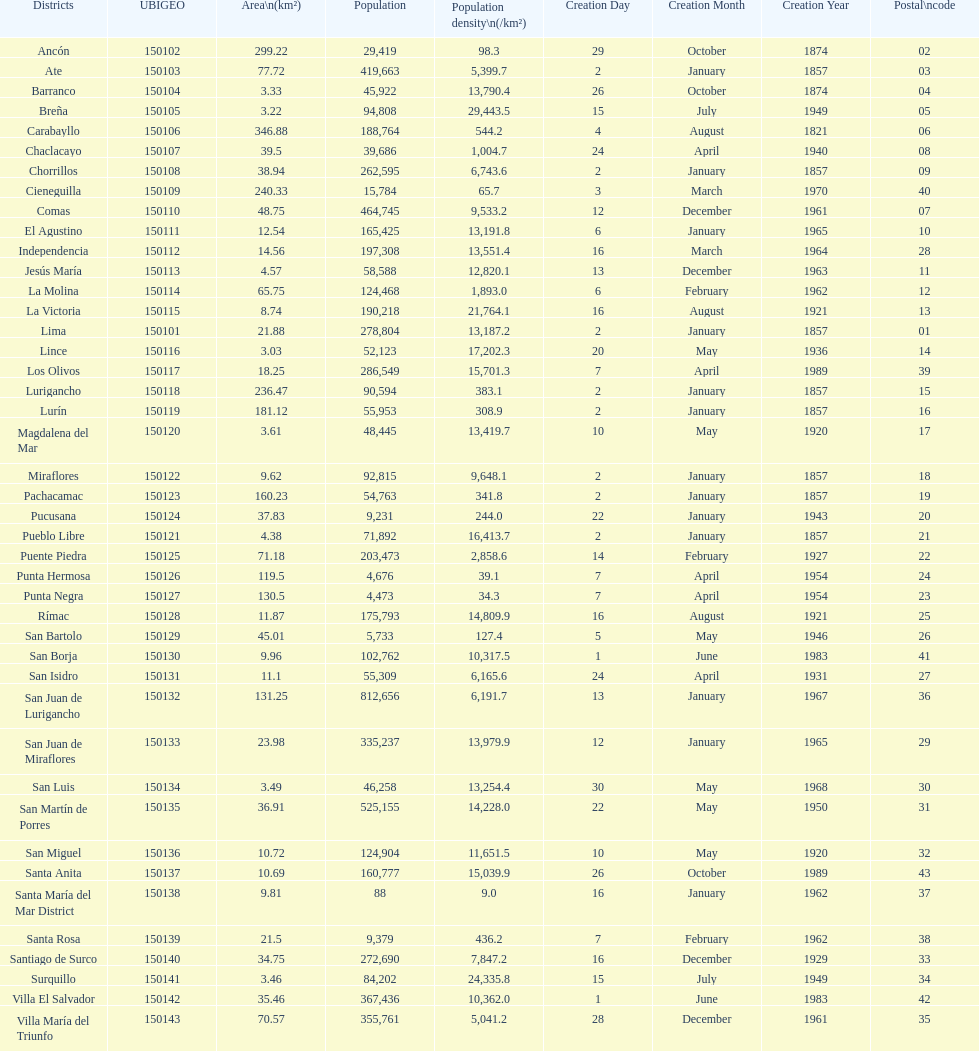How many districts are there in this city? 43. 